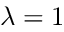Convert formula to latex. <formula><loc_0><loc_0><loc_500><loc_500>\lambda = 1</formula> 